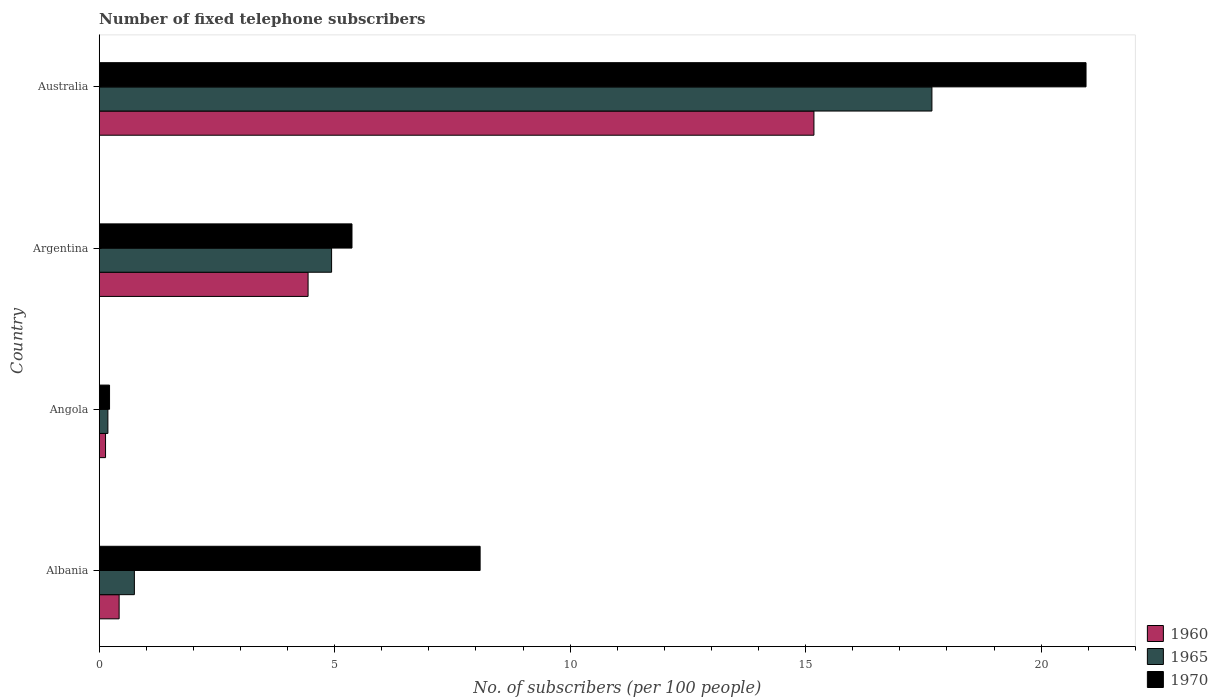How many different coloured bars are there?
Offer a very short reply. 3. Are the number of bars per tick equal to the number of legend labels?
Offer a very short reply. Yes. Are the number of bars on each tick of the Y-axis equal?
Ensure brevity in your answer.  Yes. What is the label of the 1st group of bars from the top?
Provide a succinct answer. Australia. What is the number of fixed telephone subscribers in 1960 in Albania?
Your answer should be very brief. 0.42. Across all countries, what is the maximum number of fixed telephone subscribers in 1960?
Make the answer very short. 15.18. Across all countries, what is the minimum number of fixed telephone subscribers in 1960?
Provide a short and direct response. 0.13. In which country was the number of fixed telephone subscribers in 1960 maximum?
Your answer should be compact. Australia. In which country was the number of fixed telephone subscribers in 1970 minimum?
Offer a terse response. Angola. What is the total number of fixed telephone subscribers in 1960 in the graph?
Make the answer very short. 20.17. What is the difference between the number of fixed telephone subscribers in 1960 in Albania and that in Argentina?
Make the answer very short. -4.01. What is the difference between the number of fixed telephone subscribers in 1965 in Albania and the number of fixed telephone subscribers in 1960 in Angola?
Make the answer very short. 0.61. What is the average number of fixed telephone subscribers in 1960 per country?
Keep it short and to the point. 5.04. What is the difference between the number of fixed telephone subscribers in 1970 and number of fixed telephone subscribers in 1960 in Albania?
Give a very brief answer. 7.67. What is the ratio of the number of fixed telephone subscribers in 1960 in Angola to that in Argentina?
Your response must be concise. 0.03. Is the number of fixed telephone subscribers in 1965 in Angola less than that in Argentina?
Provide a short and direct response. Yes. Is the difference between the number of fixed telephone subscribers in 1970 in Angola and Argentina greater than the difference between the number of fixed telephone subscribers in 1960 in Angola and Argentina?
Provide a short and direct response. No. What is the difference between the highest and the second highest number of fixed telephone subscribers in 1965?
Offer a very short reply. 12.75. What is the difference between the highest and the lowest number of fixed telephone subscribers in 1965?
Keep it short and to the point. 17.5. Is the sum of the number of fixed telephone subscribers in 1960 in Albania and Australia greater than the maximum number of fixed telephone subscribers in 1965 across all countries?
Give a very brief answer. No. What does the 3rd bar from the top in Angola represents?
Ensure brevity in your answer.  1960. What does the 1st bar from the bottom in Argentina represents?
Keep it short and to the point. 1960. Is it the case that in every country, the sum of the number of fixed telephone subscribers in 1970 and number of fixed telephone subscribers in 1960 is greater than the number of fixed telephone subscribers in 1965?
Ensure brevity in your answer.  Yes. How many bars are there?
Provide a short and direct response. 12. Are the values on the major ticks of X-axis written in scientific E-notation?
Give a very brief answer. No. Does the graph contain any zero values?
Give a very brief answer. No. Does the graph contain grids?
Your response must be concise. No. Where does the legend appear in the graph?
Provide a short and direct response. Bottom right. What is the title of the graph?
Your response must be concise. Number of fixed telephone subscribers. What is the label or title of the X-axis?
Provide a succinct answer. No. of subscribers (per 100 people). What is the label or title of the Y-axis?
Offer a terse response. Country. What is the No. of subscribers (per 100 people) in 1960 in Albania?
Provide a short and direct response. 0.42. What is the No. of subscribers (per 100 people) in 1965 in Albania?
Make the answer very short. 0.75. What is the No. of subscribers (per 100 people) in 1970 in Albania?
Give a very brief answer. 8.09. What is the No. of subscribers (per 100 people) of 1960 in Angola?
Offer a very short reply. 0.13. What is the No. of subscribers (per 100 people) of 1965 in Angola?
Keep it short and to the point. 0.18. What is the No. of subscribers (per 100 people) of 1970 in Angola?
Offer a terse response. 0.22. What is the No. of subscribers (per 100 people) in 1960 in Argentina?
Your answer should be compact. 4.43. What is the No. of subscribers (per 100 people) in 1965 in Argentina?
Your response must be concise. 4.93. What is the No. of subscribers (per 100 people) in 1970 in Argentina?
Ensure brevity in your answer.  5.37. What is the No. of subscribers (per 100 people) in 1960 in Australia?
Provide a short and direct response. 15.18. What is the No. of subscribers (per 100 people) in 1965 in Australia?
Keep it short and to the point. 17.68. What is the No. of subscribers (per 100 people) of 1970 in Australia?
Make the answer very short. 20.95. Across all countries, what is the maximum No. of subscribers (per 100 people) in 1960?
Your response must be concise. 15.18. Across all countries, what is the maximum No. of subscribers (per 100 people) in 1965?
Your response must be concise. 17.68. Across all countries, what is the maximum No. of subscribers (per 100 people) in 1970?
Provide a short and direct response. 20.95. Across all countries, what is the minimum No. of subscribers (per 100 people) of 1960?
Offer a very short reply. 0.13. Across all countries, what is the minimum No. of subscribers (per 100 people) of 1965?
Ensure brevity in your answer.  0.18. Across all countries, what is the minimum No. of subscribers (per 100 people) in 1970?
Give a very brief answer. 0.22. What is the total No. of subscribers (per 100 people) of 1960 in the graph?
Provide a short and direct response. 20.17. What is the total No. of subscribers (per 100 people) in 1965 in the graph?
Offer a very short reply. 23.55. What is the total No. of subscribers (per 100 people) of 1970 in the graph?
Offer a very short reply. 34.63. What is the difference between the No. of subscribers (per 100 people) of 1960 in Albania and that in Angola?
Your answer should be compact. 0.29. What is the difference between the No. of subscribers (per 100 people) in 1965 in Albania and that in Angola?
Give a very brief answer. 0.56. What is the difference between the No. of subscribers (per 100 people) in 1970 in Albania and that in Angola?
Your answer should be very brief. 7.87. What is the difference between the No. of subscribers (per 100 people) in 1960 in Albania and that in Argentina?
Keep it short and to the point. -4.01. What is the difference between the No. of subscribers (per 100 people) in 1965 in Albania and that in Argentina?
Your answer should be compact. -4.19. What is the difference between the No. of subscribers (per 100 people) in 1970 in Albania and that in Argentina?
Your response must be concise. 2.72. What is the difference between the No. of subscribers (per 100 people) of 1960 in Albania and that in Australia?
Ensure brevity in your answer.  -14.75. What is the difference between the No. of subscribers (per 100 people) in 1965 in Albania and that in Australia?
Offer a very short reply. -16.93. What is the difference between the No. of subscribers (per 100 people) of 1970 in Albania and that in Australia?
Your answer should be compact. -12.87. What is the difference between the No. of subscribers (per 100 people) of 1960 in Angola and that in Argentina?
Offer a terse response. -4.3. What is the difference between the No. of subscribers (per 100 people) of 1965 in Angola and that in Argentina?
Your response must be concise. -4.75. What is the difference between the No. of subscribers (per 100 people) in 1970 in Angola and that in Argentina?
Give a very brief answer. -5.15. What is the difference between the No. of subscribers (per 100 people) of 1960 in Angola and that in Australia?
Your answer should be compact. -15.04. What is the difference between the No. of subscribers (per 100 people) in 1965 in Angola and that in Australia?
Keep it short and to the point. -17.5. What is the difference between the No. of subscribers (per 100 people) in 1970 in Angola and that in Australia?
Offer a terse response. -20.73. What is the difference between the No. of subscribers (per 100 people) in 1960 in Argentina and that in Australia?
Offer a very short reply. -10.74. What is the difference between the No. of subscribers (per 100 people) of 1965 in Argentina and that in Australia?
Keep it short and to the point. -12.75. What is the difference between the No. of subscribers (per 100 people) of 1970 in Argentina and that in Australia?
Make the answer very short. -15.59. What is the difference between the No. of subscribers (per 100 people) of 1960 in Albania and the No. of subscribers (per 100 people) of 1965 in Angola?
Ensure brevity in your answer.  0.24. What is the difference between the No. of subscribers (per 100 people) of 1960 in Albania and the No. of subscribers (per 100 people) of 1970 in Angola?
Give a very brief answer. 0.2. What is the difference between the No. of subscribers (per 100 people) of 1965 in Albania and the No. of subscribers (per 100 people) of 1970 in Angola?
Provide a succinct answer. 0.53. What is the difference between the No. of subscribers (per 100 people) of 1960 in Albania and the No. of subscribers (per 100 people) of 1965 in Argentina?
Make the answer very short. -4.51. What is the difference between the No. of subscribers (per 100 people) of 1960 in Albania and the No. of subscribers (per 100 people) of 1970 in Argentina?
Keep it short and to the point. -4.94. What is the difference between the No. of subscribers (per 100 people) of 1965 in Albania and the No. of subscribers (per 100 people) of 1970 in Argentina?
Your answer should be compact. -4.62. What is the difference between the No. of subscribers (per 100 people) in 1960 in Albania and the No. of subscribers (per 100 people) in 1965 in Australia?
Provide a succinct answer. -17.26. What is the difference between the No. of subscribers (per 100 people) in 1960 in Albania and the No. of subscribers (per 100 people) in 1970 in Australia?
Offer a very short reply. -20.53. What is the difference between the No. of subscribers (per 100 people) of 1965 in Albania and the No. of subscribers (per 100 people) of 1970 in Australia?
Your answer should be very brief. -20.21. What is the difference between the No. of subscribers (per 100 people) of 1960 in Angola and the No. of subscribers (per 100 people) of 1965 in Argentina?
Ensure brevity in your answer.  -4.8. What is the difference between the No. of subscribers (per 100 people) of 1960 in Angola and the No. of subscribers (per 100 people) of 1970 in Argentina?
Provide a succinct answer. -5.23. What is the difference between the No. of subscribers (per 100 people) of 1965 in Angola and the No. of subscribers (per 100 people) of 1970 in Argentina?
Make the answer very short. -5.18. What is the difference between the No. of subscribers (per 100 people) in 1960 in Angola and the No. of subscribers (per 100 people) in 1965 in Australia?
Offer a very short reply. -17.55. What is the difference between the No. of subscribers (per 100 people) of 1960 in Angola and the No. of subscribers (per 100 people) of 1970 in Australia?
Give a very brief answer. -20.82. What is the difference between the No. of subscribers (per 100 people) in 1965 in Angola and the No. of subscribers (per 100 people) in 1970 in Australia?
Your response must be concise. -20.77. What is the difference between the No. of subscribers (per 100 people) in 1960 in Argentina and the No. of subscribers (per 100 people) in 1965 in Australia?
Offer a terse response. -13.25. What is the difference between the No. of subscribers (per 100 people) in 1960 in Argentina and the No. of subscribers (per 100 people) in 1970 in Australia?
Make the answer very short. -16.52. What is the difference between the No. of subscribers (per 100 people) in 1965 in Argentina and the No. of subscribers (per 100 people) in 1970 in Australia?
Give a very brief answer. -16.02. What is the average No. of subscribers (per 100 people) in 1960 per country?
Your response must be concise. 5.04. What is the average No. of subscribers (per 100 people) in 1965 per country?
Offer a terse response. 5.89. What is the average No. of subscribers (per 100 people) of 1970 per country?
Keep it short and to the point. 8.66. What is the difference between the No. of subscribers (per 100 people) of 1960 and No. of subscribers (per 100 people) of 1965 in Albania?
Provide a short and direct response. -0.32. What is the difference between the No. of subscribers (per 100 people) of 1960 and No. of subscribers (per 100 people) of 1970 in Albania?
Keep it short and to the point. -7.67. What is the difference between the No. of subscribers (per 100 people) in 1965 and No. of subscribers (per 100 people) in 1970 in Albania?
Your answer should be compact. -7.34. What is the difference between the No. of subscribers (per 100 people) in 1960 and No. of subscribers (per 100 people) in 1965 in Angola?
Keep it short and to the point. -0.05. What is the difference between the No. of subscribers (per 100 people) in 1960 and No. of subscribers (per 100 people) in 1970 in Angola?
Keep it short and to the point. -0.09. What is the difference between the No. of subscribers (per 100 people) in 1965 and No. of subscribers (per 100 people) in 1970 in Angola?
Ensure brevity in your answer.  -0.04. What is the difference between the No. of subscribers (per 100 people) in 1960 and No. of subscribers (per 100 people) in 1965 in Argentina?
Your answer should be compact. -0.5. What is the difference between the No. of subscribers (per 100 people) of 1960 and No. of subscribers (per 100 people) of 1970 in Argentina?
Provide a succinct answer. -0.93. What is the difference between the No. of subscribers (per 100 people) in 1965 and No. of subscribers (per 100 people) in 1970 in Argentina?
Provide a short and direct response. -0.43. What is the difference between the No. of subscribers (per 100 people) in 1960 and No. of subscribers (per 100 people) in 1965 in Australia?
Provide a short and direct response. -2.51. What is the difference between the No. of subscribers (per 100 people) of 1960 and No. of subscribers (per 100 people) of 1970 in Australia?
Give a very brief answer. -5.78. What is the difference between the No. of subscribers (per 100 people) in 1965 and No. of subscribers (per 100 people) in 1970 in Australia?
Give a very brief answer. -3.27. What is the ratio of the No. of subscribers (per 100 people) in 1960 in Albania to that in Angola?
Ensure brevity in your answer.  3.15. What is the ratio of the No. of subscribers (per 100 people) in 1965 in Albania to that in Angola?
Provide a short and direct response. 4.06. What is the ratio of the No. of subscribers (per 100 people) of 1970 in Albania to that in Angola?
Your response must be concise. 36.88. What is the ratio of the No. of subscribers (per 100 people) of 1960 in Albania to that in Argentina?
Your response must be concise. 0.1. What is the ratio of the No. of subscribers (per 100 people) of 1965 in Albania to that in Argentina?
Keep it short and to the point. 0.15. What is the ratio of the No. of subscribers (per 100 people) in 1970 in Albania to that in Argentina?
Your answer should be compact. 1.51. What is the ratio of the No. of subscribers (per 100 people) of 1960 in Albania to that in Australia?
Give a very brief answer. 0.03. What is the ratio of the No. of subscribers (per 100 people) in 1965 in Albania to that in Australia?
Offer a terse response. 0.04. What is the ratio of the No. of subscribers (per 100 people) in 1970 in Albania to that in Australia?
Ensure brevity in your answer.  0.39. What is the ratio of the No. of subscribers (per 100 people) of 1960 in Angola to that in Argentina?
Keep it short and to the point. 0.03. What is the ratio of the No. of subscribers (per 100 people) of 1965 in Angola to that in Argentina?
Your response must be concise. 0.04. What is the ratio of the No. of subscribers (per 100 people) of 1970 in Angola to that in Argentina?
Give a very brief answer. 0.04. What is the ratio of the No. of subscribers (per 100 people) of 1960 in Angola to that in Australia?
Provide a short and direct response. 0.01. What is the ratio of the No. of subscribers (per 100 people) of 1965 in Angola to that in Australia?
Your answer should be compact. 0.01. What is the ratio of the No. of subscribers (per 100 people) in 1970 in Angola to that in Australia?
Your answer should be compact. 0.01. What is the ratio of the No. of subscribers (per 100 people) in 1960 in Argentina to that in Australia?
Your answer should be compact. 0.29. What is the ratio of the No. of subscribers (per 100 people) in 1965 in Argentina to that in Australia?
Provide a succinct answer. 0.28. What is the ratio of the No. of subscribers (per 100 people) in 1970 in Argentina to that in Australia?
Provide a short and direct response. 0.26. What is the difference between the highest and the second highest No. of subscribers (per 100 people) in 1960?
Your response must be concise. 10.74. What is the difference between the highest and the second highest No. of subscribers (per 100 people) of 1965?
Provide a short and direct response. 12.75. What is the difference between the highest and the second highest No. of subscribers (per 100 people) of 1970?
Give a very brief answer. 12.87. What is the difference between the highest and the lowest No. of subscribers (per 100 people) in 1960?
Provide a succinct answer. 15.04. What is the difference between the highest and the lowest No. of subscribers (per 100 people) in 1965?
Provide a short and direct response. 17.5. What is the difference between the highest and the lowest No. of subscribers (per 100 people) of 1970?
Your response must be concise. 20.73. 